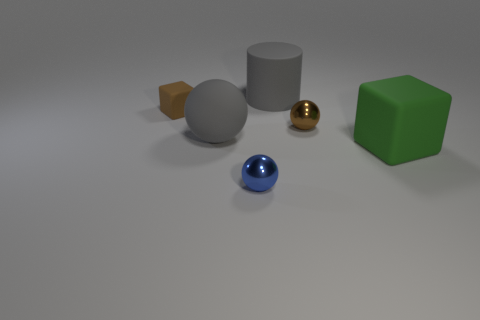Subtract all large gray matte balls. How many balls are left? 2 Add 4 large balls. How many objects exist? 10 Subtract all blocks. How many objects are left? 4 Subtract all red balls. Subtract all green cylinders. How many balls are left? 3 Add 2 large gray rubber spheres. How many large gray rubber spheres exist? 3 Subtract 0 blue cylinders. How many objects are left? 6 Subtract all spheres. Subtract all green rubber cubes. How many objects are left? 2 Add 1 tiny blue metallic things. How many tiny blue metallic things are left? 2 